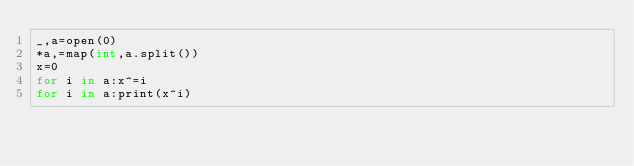Convert code to text. <code><loc_0><loc_0><loc_500><loc_500><_Cython_>_,a=open(0)
*a,=map(int,a.split())
x=0
for i in a:x^=i
for i in a:print(x^i)</code> 